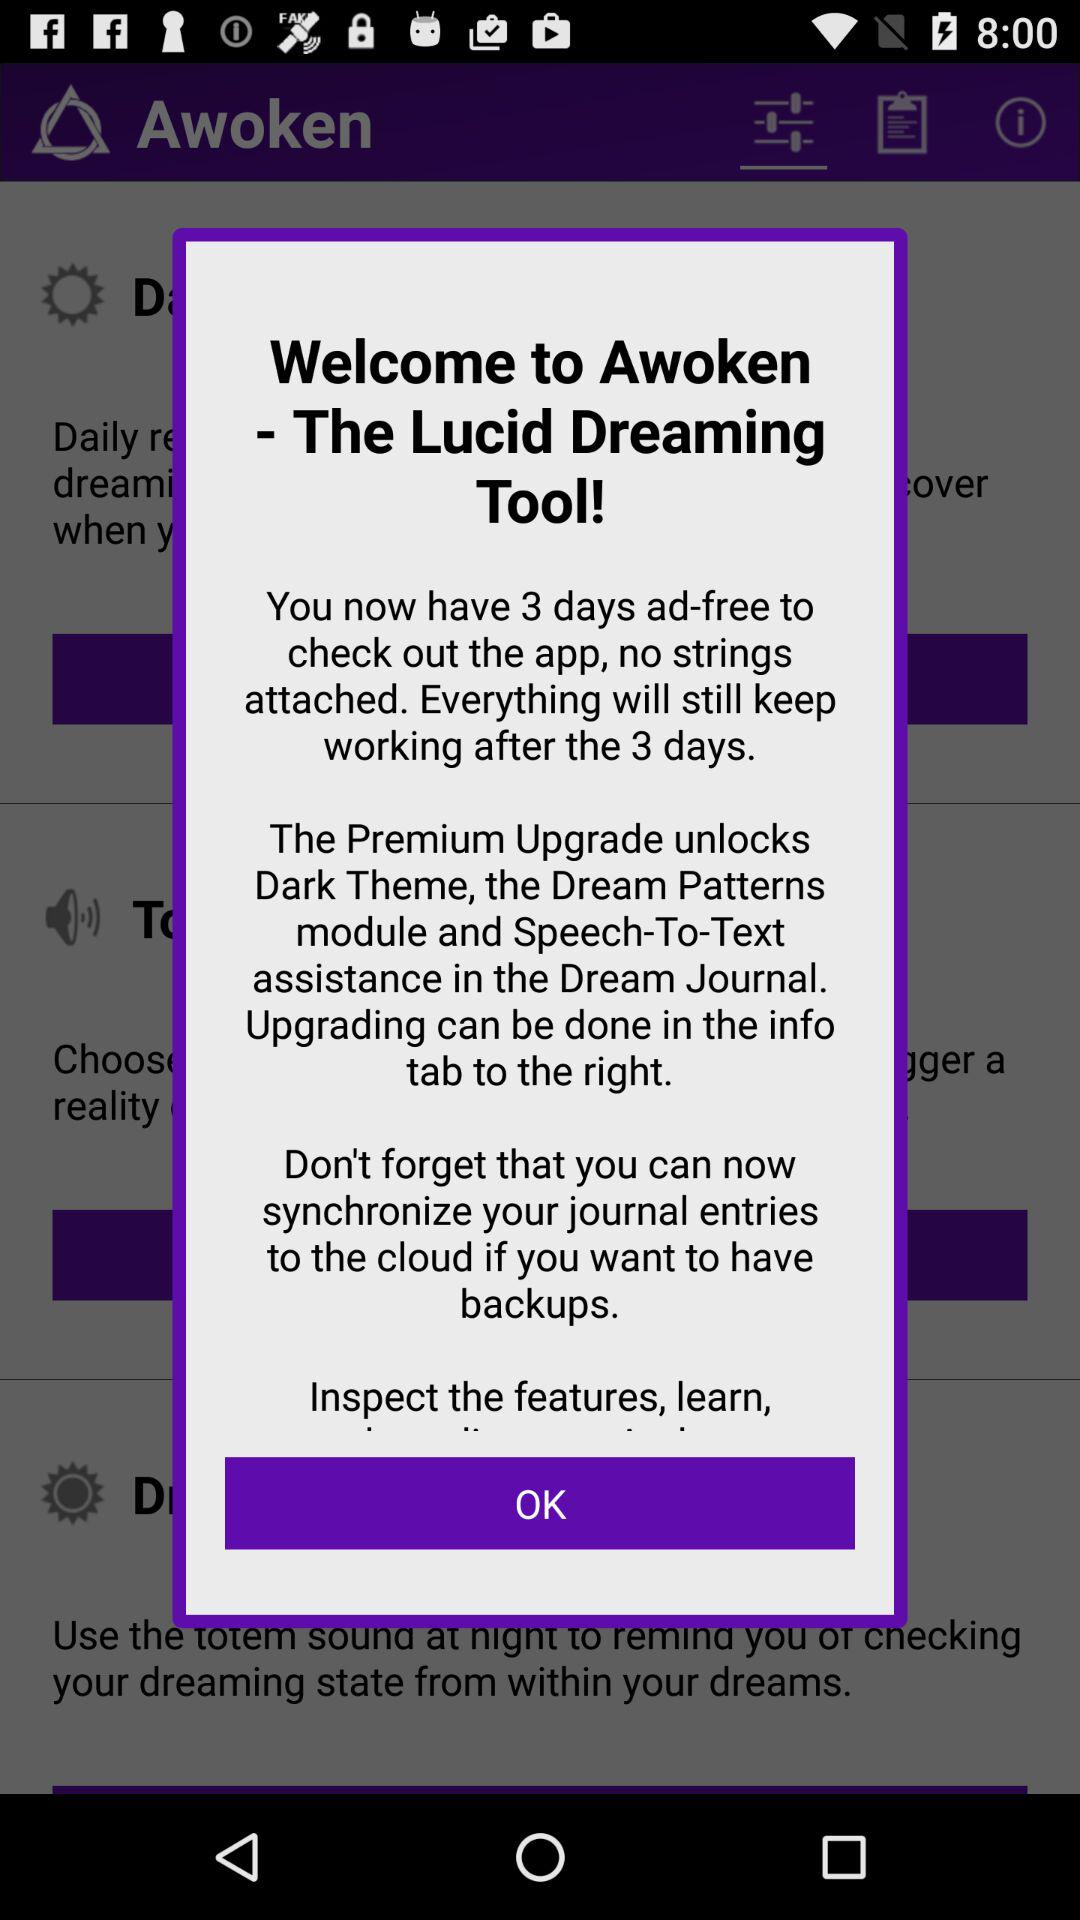What features will be unlocked with the premium upgrade? The premium upgrade will unlock the dark theme, the Dream Patterns module and speech-to-text assistance in the dream journal. 